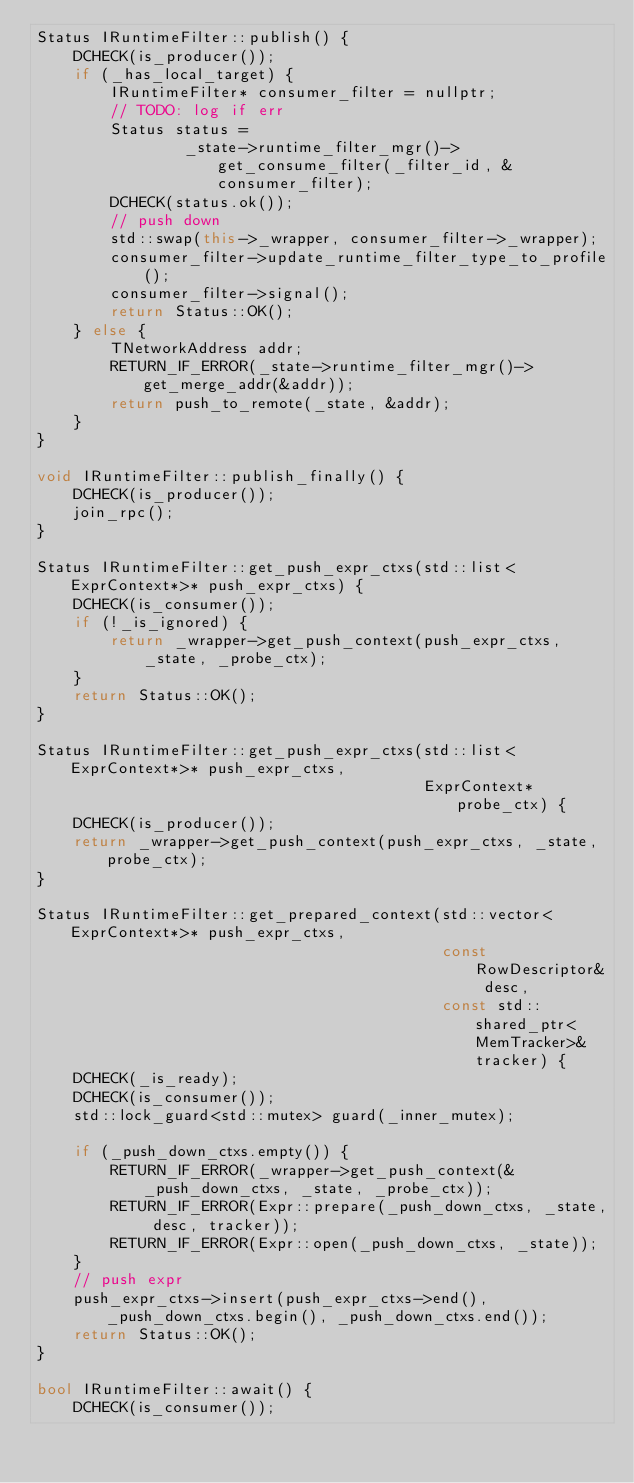Convert code to text. <code><loc_0><loc_0><loc_500><loc_500><_C++_>Status IRuntimeFilter::publish() {
    DCHECK(is_producer());
    if (_has_local_target) {
        IRuntimeFilter* consumer_filter = nullptr;
        // TODO: log if err
        Status status =
                _state->runtime_filter_mgr()->get_consume_filter(_filter_id, &consumer_filter);
        DCHECK(status.ok());
        // push down
        std::swap(this->_wrapper, consumer_filter->_wrapper);
        consumer_filter->update_runtime_filter_type_to_profile();
        consumer_filter->signal();
        return Status::OK();
    } else {
        TNetworkAddress addr;
        RETURN_IF_ERROR(_state->runtime_filter_mgr()->get_merge_addr(&addr));
        return push_to_remote(_state, &addr);
    }
}

void IRuntimeFilter::publish_finally() {
    DCHECK(is_producer());
    join_rpc();
}

Status IRuntimeFilter::get_push_expr_ctxs(std::list<ExprContext*>* push_expr_ctxs) {
    DCHECK(is_consumer());
    if (!_is_ignored) {
        return _wrapper->get_push_context(push_expr_ctxs, _state, _probe_ctx);
    }
    return Status::OK();
}

Status IRuntimeFilter::get_push_expr_ctxs(std::list<ExprContext*>* push_expr_ctxs,
                                          ExprContext* probe_ctx) {
    DCHECK(is_producer());
    return _wrapper->get_push_context(push_expr_ctxs, _state, probe_ctx);
}

Status IRuntimeFilter::get_prepared_context(std::vector<ExprContext*>* push_expr_ctxs,
                                            const RowDescriptor& desc,
                                            const std::shared_ptr<MemTracker>& tracker) {
    DCHECK(_is_ready);
    DCHECK(is_consumer());
    std::lock_guard<std::mutex> guard(_inner_mutex);

    if (_push_down_ctxs.empty()) {
        RETURN_IF_ERROR(_wrapper->get_push_context(&_push_down_ctxs, _state, _probe_ctx));
        RETURN_IF_ERROR(Expr::prepare(_push_down_ctxs, _state, desc, tracker));
        RETURN_IF_ERROR(Expr::open(_push_down_ctxs, _state));
    }
    // push expr
    push_expr_ctxs->insert(push_expr_ctxs->end(), _push_down_ctxs.begin(), _push_down_ctxs.end());
    return Status::OK();
}

bool IRuntimeFilter::await() {
    DCHECK(is_consumer());</code> 